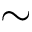Convert formula to latex. <formula><loc_0><loc_0><loc_500><loc_500>\sim</formula> 